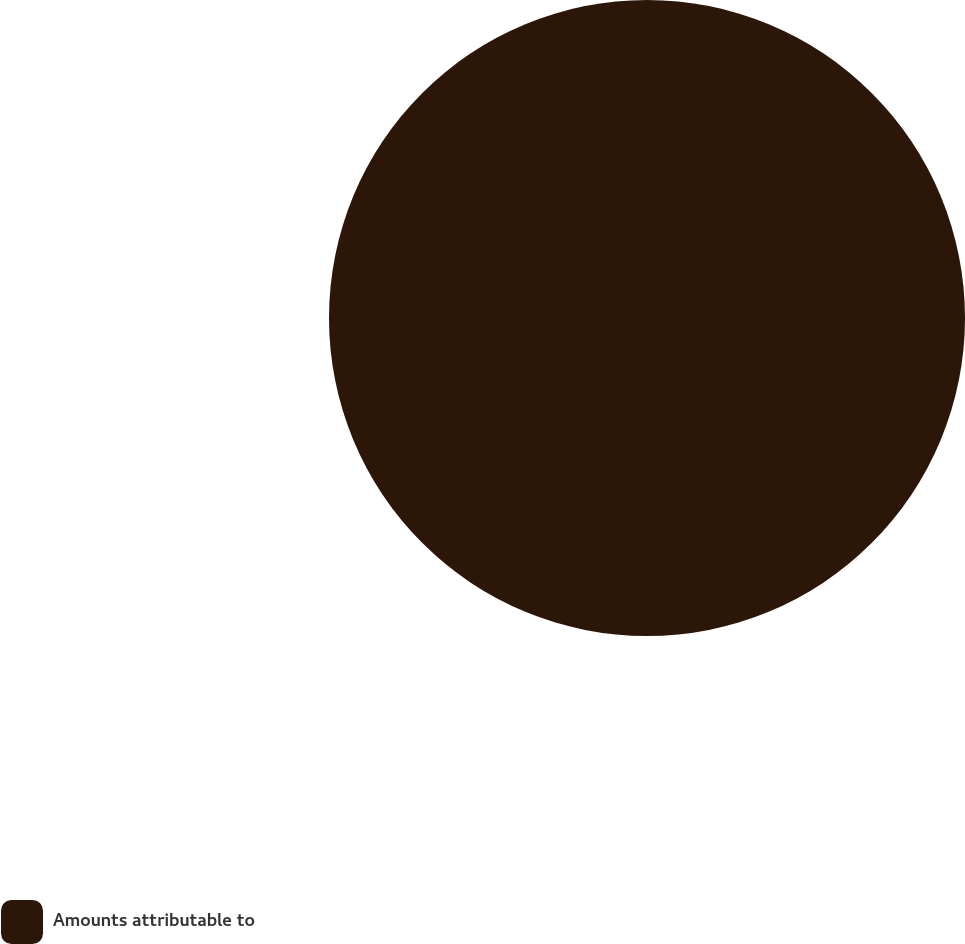Convert chart. <chart><loc_0><loc_0><loc_500><loc_500><pie_chart><fcel>Amounts attributable to<nl><fcel>100.0%<nl></chart> 